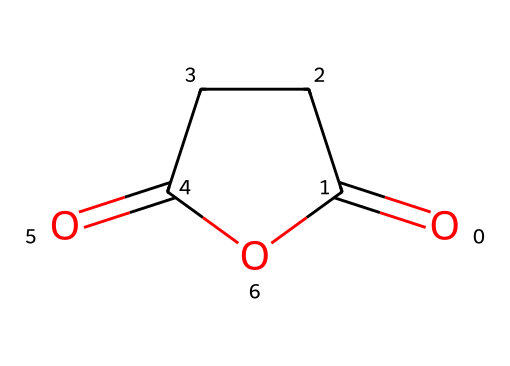What is the total number of carbon atoms in the structural formula of succinic anhydride? The SMILES representation indicates that there are four carbon atoms present in the structure, as evident from the two distinct carbonyl groups and the carbon framework.
Answer: four What type of bonding is mostly present in succinic anhydride? The presence of carbonyl (C=O) and carbon-carbon (C-C) bonds denotes that there are both double and single bonds in the molecular structure.
Answer: covalent How many oxygen atoms are present in succinic anhydride? The structural formula indicates there are two carbonyl groups and one hydroxyl group (from the anhydride formation), totaling three oxygen atoms in the structure.
Answer: three What functional group characterizes the structure of succinic anhydride? The presence of the two carbonyl groups (C=O) and the bridging carbon indicates that succinic anhydride contains an anhydride functional group.
Answer: anhydride What is the primary use of succinic anhydride in flame retardants? Succinic anhydride serves as a key precursor in obtaining other materials that provide flame-retardant properties, acting as a component in polymer formulations.
Answer: precursor 